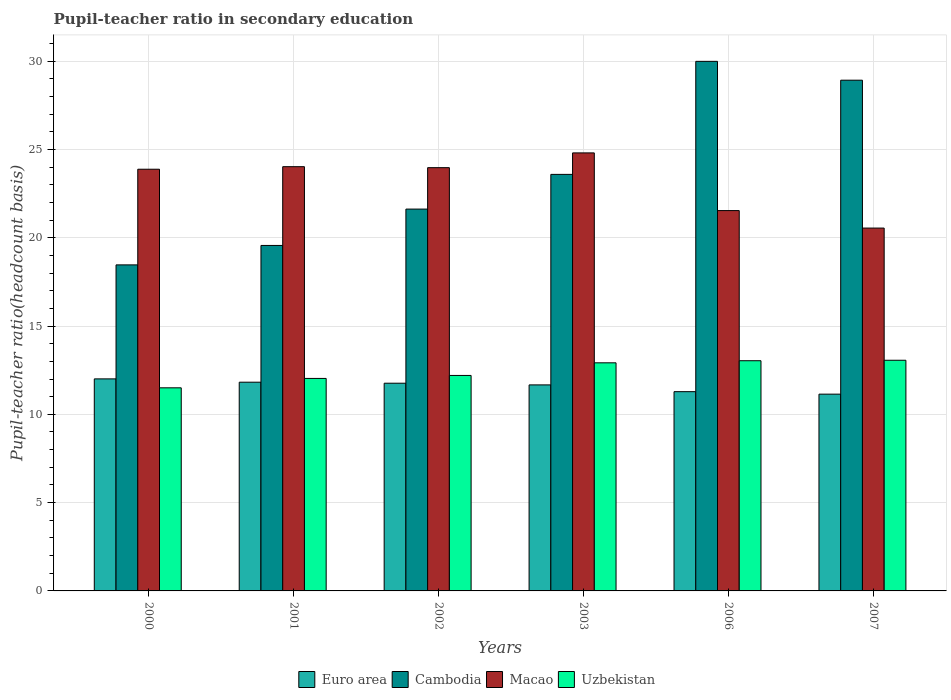How many different coloured bars are there?
Provide a succinct answer. 4. How many groups of bars are there?
Provide a short and direct response. 6. How many bars are there on the 4th tick from the right?
Keep it short and to the point. 4. What is the label of the 2nd group of bars from the left?
Your answer should be compact. 2001. In how many cases, is the number of bars for a given year not equal to the number of legend labels?
Provide a short and direct response. 0. What is the pupil-teacher ratio in secondary education in Uzbekistan in 2001?
Provide a succinct answer. 12.03. Across all years, what is the maximum pupil-teacher ratio in secondary education in Uzbekistan?
Give a very brief answer. 13.06. Across all years, what is the minimum pupil-teacher ratio in secondary education in Euro area?
Offer a terse response. 11.14. In which year was the pupil-teacher ratio in secondary education in Uzbekistan maximum?
Provide a short and direct response. 2007. What is the total pupil-teacher ratio in secondary education in Uzbekistan in the graph?
Provide a short and direct response. 74.75. What is the difference between the pupil-teacher ratio in secondary education in Uzbekistan in 2002 and that in 2003?
Your answer should be compact. -0.72. What is the difference between the pupil-teacher ratio in secondary education in Uzbekistan in 2000 and the pupil-teacher ratio in secondary education in Macao in 2006?
Offer a very short reply. -10.04. What is the average pupil-teacher ratio in secondary education in Euro area per year?
Your answer should be compact. 11.61. In the year 2002, what is the difference between the pupil-teacher ratio in secondary education in Uzbekistan and pupil-teacher ratio in secondary education in Euro area?
Keep it short and to the point. 0.44. What is the ratio of the pupil-teacher ratio in secondary education in Uzbekistan in 2003 to that in 2007?
Give a very brief answer. 0.99. Is the difference between the pupil-teacher ratio in secondary education in Uzbekistan in 2000 and 2001 greater than the difference between the pupil-teacher ratio in secondary education in Euro area in 2000 and 2001?
Make the answer very short. No. What is the difference between the highest and the second highest pupil-teacher ratio in secondary education in Uzbekistan?
Your response must be concise. 0.03. What is the difference between the highest and the lowest pupil-teacher ratio in secondary education in Macao?
Keep it short and to the point. 4.26. In how many years, is the pupil-teacher ratio in secondary education in Uzbekistan greater than the average pupil-teacher ratio in secondary education in Uzbekistan taken over all years?
Make the answer very short. 3. Is it the case that in every year, the sum of the pupil-teacher ratio in secondary education in Euro area and pupil-teacher ratio in secondary education in Cambodia is greater than the sum of pupil-teacher ratio in secondary education in Uzbekistan and pupil-teacher ratio in secondary education in Macao?
Your response must be concise. Yes. What does the 3rd bar from the left in 2001 represents?
Your response must be concise. Macao. What does the 2nd bar from the right in 2007 represents?
Ensure brevity in your answer.  Macao. Are all the bars in the graph horizontal?
Your answer should be very brief. No. What is the difference between two consecutive major ticks on the Y-axis?
Your answer should be compact. 5. Are the values on the major ticks of Y-axis written in scientific E-notation?
Provide a short and direct response. No. Does the graph contain any zero values?
Give a very brief answer. No. What is the title of the graph?
Make the answer very short. Pupil-teacher ratio in secondary education. Does "Ghana" appear as one of the legend labels in the graph?
Provide a succinct answer. No. What is the label or title of the X-axis?
Give a very brief answer. Years. What is the label or title of the Y-axis?
Offer a terse response. Pupil-teacher ratio(headcount basis). What is the Pupil-teacher ratio(headcount basis) of Euro area in 2000?
Give a very brief answer. 12.01. What is the Pupil-teacher ratio(headcount basis) in Cambodia in 2000?
Give a very brief answer. 18.46. What is the Pupil-teacher ratio(headcount basis) of Macao in 2000?
Your response must be concise. 23.88. What is the Pupil-teacher ratio(headcount basis) in Uzbekistan in 2000?
Make the answer very short. 11.5. What is the Pupil-teacher ratio(headcount basis) of Euro area in 2001?
Offer a very short reply. 11.82. What is the Pupil-teacher ratio(headcount basis) in Cambodia in 2001?
Your answer should be compact. 19.56. What is the Pupil-teacher ratio(headcount basis) of Macao in 2001?
Provide a short and direct response. 24.02. What is the Pupil-teacher ratio(headcount basis) in Uzbekistan in 2001?
Give a very brief answer. 12.03. What is the Pupil-teacher ratio(headcount basis) in Euro area in 2002?
Ensure brevity in your answer.  11.76. What is the Pupil-teacher ratio(headcount basis) in Cambodia in 2002?
Give a very brief answer. 21.62. What is the Pupil-teacher ratio(headcount basis) of Macao in 2002?
Provide a short and direct response. 23.97. What is the Pupil-teacher ratio(headcount basis) in Uzbekistan in 2002?
Your response must be concise. 12.2. What is the Pupil-teacher ratio(headcount basis) in Euro area in 2003?
Provide a short and direct response. 11.67. What is the Pupil-teacher ratio(headcount basis) in Cambodia in 2003?
Provide a succinct answer. 23.59. What is the Pupil-teacher ratio(headcount basis) in Macao in 2003?
Provide a short and direct response. 24.8. What is the Pupil-teacher ratio(headcount basis) in Uzbekistan in 2003?
Keep it short and to the point. 12.92. What is the Pupil-teacher ratio(headcount basis) in Euro area in 2006?
Offer a very short reply. 11.28. What is the Pupil-teacher ratio(headcount basis) of Cambodia in 2006?
Offer a terse response. 29.99. What is the Pupil-teacher ratio(headcount basis) of Macao in 2006?
Provide a short and direct response. 21.54. What is the Pupil-teacher ratio(headcount basis) of Uzbekistan in 2006?
Offer a very short reply. 13.04. What is the Pupil-teacher ratio(headcount basis) in Euro area in 2007?
Provide a short and direct response. 11.14. What is the Pupil-teacher ratio(headcount basis) of Cambodia in 2007?
Provide a short and direct response. 28.92. What is the Pupil-teacher ratio(headcount basis) of Macao in 2007?
Your answer should be compact. 20.55. What is the Pupil-teacher ratio(headcount basis) of Uzbekistan in 2007?
Provide a short and direct response. 13.06. Across all years, what is the maximum Pupil-teacher ratio(headcount basis) of Euro area?
Give a very brief answer. 12.01. Across all years, what is the maximum Pupil-teacher ratio(headcount basis) in Cambodia?
Make the answer very short. 29.99. Across all years, what is the maximum Pupil-teacher ratio(headcount basis) of Macao?
Your response must be concise. 24.8. Across all years, what is the maximum Pupil-teacher ratio(headcount basis) of Uzbekistan?
Ensure brevity in your answer.  13.06. Across all years, what is the minimum Pupil-teacher ratio(headcount basis) in Euro area?
Your response must be concise. 11.14. Across all years, what is the minimum Pupil-teacher ratio(headcount basis) in Cambodia?
Your answer should be very brief. 18.46. Across all years, what is the minimum Pupil-teacher ratio(headcount basis) in Macao?
Ensure brevity in your answer.  20.55. Across all years, what is the minimum Pupil-teacher ratio(headcount basis) of Uzbekistan?
Keep it short and to the point. 11.5. What is the total Pupil-teacher ratio(headcount basis) in Euro area in the graph?
Give a very brief answer. 69.68. What is the total Pupil-teacher ratio(headcount basis) in Cambodia in the graph?
Offer a terse response. 142.15. What is the total Pupil-teacher ratio(headcount basis) in Macao in the graph?
Your answer should be very brief. 138.76. What is the total Pupil-teacher ratio(headcount basis) in Uzbekistan in the graph?
Your response must be concise. 74.75. What is the difference between the Pupil-teacher ratio(headcount basis) of Euro area in 2000 and that in 2001?
Offer a terse response. 0.19. What is the difference between the Pupil-teacher ratio(headcount basis) in Cambodia in 2000 and that in 2001?
Give a very brief answer. -1.1. What is the difference between the Pupil-teacher ratio(headcount basis) of Macao in 2000 and that in 2001?
Offer a terse response. -0.14. What is the difference between the Pupil-teacher ratio(headcount basis) in Uzbekistan in 2000 and that in 2001?
Your response must be concise. -0.53. What is the difference between the Pupil-teacher ratio(headcount basis) in Euro area in 2000 and that in 2002?
Your answer should be very brief. 0.25. What is the difference between the Pupil-teacher ratio(headcount basis) in Cambodia in 2000 and that in 2002?
Your answer should be very brief. -3.16. What is the difference between the Pupil-teacher ratio(headcount basis) of Macao in 2000 and that in 2002?
Provide a short and direct response. -0.09. What is the difference between the Pupil-teacher ratio(headcount basis) of Uzbekistan in 2000 and that in 2002?
Provide a short and direct response. -0.7. What is the difference between the Pupil-teacher ratio(headcount basis) of Euro area in 2000 and that in 2003?
Make the answer very short. 0.34. What is the difference between the Pupil-teacher ratio(headcount basis) in Cambodia in 2000 and that in 2003?
Offer a terse response. -5.12. What is the difference between the Pupil-teacher ratio(headcount basis) in Macao in 2000 and that in 2003?
Make the answer very short. -0.92. What is the difference between the Pupil-teacher ratio(headcount basis) in Uzbekistan in 2000 and that in 2003?
Offer a terse response. -1.42. What is the difference between the Pupil-teacher ratio(headcount basis) in Euro area in 2000 and that in 2006?
Your answer should be very brief. 0.72. What is the difference between the Pupil-teacher ratio(headcount basis) in Cambodia in 2000 and that in 2006?
Offer a very short reply. -11.53. What is the difference between the Pupil-teacher ratio(headcount basis) of Macao in 2000 and that in 2006?
Ensure brevity in your answer.  2.34. What is the difference between the Pupil-teacher ratio(headcount basis) in Uzbekistan in 2000 and that in 2006?
Make the answer very short. -1.53. What is the difference between the Pupil-teacher ratio(headcount basis) in Euro area in 2000 and that in 2007?
Your answer should be compact. 0.86. What is the difference between the Pupil-teacher ratio(headcount basis) of Cambodia in 2000 and that in 2007?
Give a very brief answer. -10.46. What is the difference between the Pupil-teacher ratio(headcount basis) of Macao in 2000 and that in 2007?
Make the answer very short. 3.33. What is the difference between the Pupil-teacher ratio(headcount basis) of Uzbekistan in 2000 and that in 2007?
Offer a terse response. -1.56. What is the difference between the Pupil-teacher ratio(headcount basis) in Euro area in 2001 and that in 2002?
Offer a very short reply. 0.06. What is the difference between the Pupil-teacher ratio(headcount basis) of Cambodia in 2001 and that in 2002?
Make the answer very short. -2.06. What is the difference between the Pupil-teacher ratio(headcount basis) in Macao in 2001 and that in 2002?
Make the answer very short. 0.06. What is the difference between the Pupil-teacher ratio(headcount basis) of Uzbekistan in 2001 and that in 2002?
Your response must be concise. -0.17. What is the difference between the Pupil-teacher ratio(headcount basis) of Euro area in 2001 and that in 2003?
Keep it short and to the point. 0.15. What is the difference between the Pupil-teacher ratio(headcount basis) of Cambodia in 2001 and that in 2003?
Make the answer very short. -4.02. What is the difference between the Pupil-teacher ratio(headcount basis) in Macao in 2001 and that in 2003?
Offer a very short reply. -0.78. What is the difference between the Pupil-teacher ratio(headcount basis) in Uzbekistan in 2001 and that in 2003?
Ensure brevity in your answer.  -0.88. What is the difference between the Pupil-teacher ratio(headcount basis) in Euro area in 2001 and that in 2006?
Keep it short and to the point. 0.54. What is the difference between the Pupil-teacher ratio(headcount basis) of Cambodia in 2001 and that in 2006?
Make the answer very short. -10.42. What is the difference between the Pupil-teacher ratio(headcount basis) in Macao in 2001 and that in 2006?
Your answer should be compact. 2.49. What is the difference between the Pupil-teacher ratio(headcount basis) of Uzbekistan in 2001 and that in 2006?
Make the answer very short. -1. What is the difference between the Pupil-teacher ratio(headcount basis) of Euro area in 2001 and that in 2007?
Keep it short and to the point. 0.68. What is the difference between the Pupil-teacher ratio(headcount basis) of Cambodia in 2001 and that in 2007?
Provide a short and direct response. -9.36. What is the difference between the Pupil-teacher ratio(headcount basis) in Macao in 2001 and that in 2007?
Offer a terse response. 3.48. What is the difference between the Pupil-teacher ratio(headcount basis) of Uzbekistan in 2001 and that in 2007?
Make the answer very short. -1.03. What is the difference between the Pupil-teacher ratio(headcount basis) in Euro area in 2002 and that in 2003?
Your answer should be very brief. 0.1. What is the difference between the Pupil-teacher ratio(headcount basis) of Cambodia in 2002 and that in 2003?
Keep it short and to the point. -1.97. What is the difference between the Pupil-teacher ratio(headcount basis) in Macao in 2002 and that in 2003?
Keep it short and to the point. -0.84. What is the difference between the Pupil-teacher ratio(headcount basis) of Uzbekistan in 2002 and that in 2003?
Provide a succinct answer. -0.72. What is the difference between the Pupil-teacher ratio(headcount basis) of Euro area in 2002 and that in 2006?
Your answer should be compact. 0.48. What is the difference between the Pupil-teacher ratio(headcount basis) in Cambodia in 2002 and that in 2006?
Provide a short and direct response. -8.37. What is the difference between the Pupil-teacher ratio(headcount basis) in Macao in 2002 and that in 2006?
Keep it short and to the point. 2.43. What is the difference between the Pupil-teacher ratio(headcount basis) of Uzbekistan in 2002 and that in 2006?
Your response must be concise. -0.83. What is the difference between the Pupil-teacher ratio(headcount basis) of Euro area in 2002 and that in 2007?
Keep it short and to the point. 0.62. What is the difference between the Pupil-teacher ratio(headcount basis) in Cambodia in 2002 and that in 2007?
Provide a short and direct response. -7.3. What is the difference between the Pupil-teacher ratio(headcount basis) of Macao in 2002 and that in 2007?
Ensure brevity in your answer.  3.42. What is the difference between the Pupil-teacher ratio(headcount basis) in Uzbekistan in 2002 and that in 2007?
Provide a succinct answer. -0.86. What is the difference between the Pupil-teacher ratio(headcount basis) of Euro area in 2003 and that in 2006?
Ensure brevity in your answer.  0.38. What is the difference between the Pupil-teacher ratio(headcount basis) of Cambodia in 2003 and that in 2006?
Provide a short and direct response. -6.4. What is the difference between the Pupil-teacher ratio(headcount basis) in Macao in 2003 and that in 2006?
Provide a succinct answer. 3.27. What is the difference between the Pupil-teacher ratio(headcount basis) in Uzbekistan in 2003 and that in 2006?
Give a very brief answer. -0.12. What is the difference between the Pupil-teacher ratio(headcount basis) in Euro area in 2003 and that in 2007?
Your answer should be compact. 0.52. What is the difference between the Pupil-teacher ratio(headcount basis) of Cambodia in 2003 and that in 2007?
Your answer should be very brief. -5.33. What is the difference between the Pupil-teacher ratio(headcount basis) of Macao in 2003 and that in 2007?
Offer a terse response. 4.26. What is the difference between the Pupil-teacher ratio(headcount basis) in Uzbekistan in 2003 and that in 2007?
Your answer should be very brief. -0.15. What is the difference between the Pupil-teacher ratio(headcount basis) of Euro area in 2006 and that in 2007?
Keep it short and to the point. 0.14. What is the difference between the Pupil-teacher ratio(headcount basis) in Cambodia in 2006 and that in 2007?
Ensure brevity in your answer.  1.07. What is the difference between the Pupil-teacher ratio(headcount basis) in Macao in 2006 and that in 2007?
Your answer should be very brief. 0.99. What is the difference between the Pupil-teacher ratio(headcount basis) in Uzbekistan in 2006 and that in 2007?
Offer a terse response. -0.03. What is the difference between the Pupil-teacher ratio(headcount basis) of Euro area in 2000 and the Pupil-teacher ratio(headcount basis) of Cambodia in 2001?
Ensure brevity in your answer.  -7.56. What is the difference between the Pupil-teacher ratio(headcount basis) in Euro area in 2000 and the Pupil-teacher ratio(headcount basis) in Macao in 2001?
Ensure brevity in your answer.  -12.02. What is the difference between the Pupil-teacher ratio(headcount basis) of Euro area in 2000 and the Pupil-teacher ratio(headcount basis) of Uzbekistan in 2001?
Make the answer very short. -0.03. What is the difference between the Pupil-teacher ratio(headcount basis) of Cambodia in 2000 and the Pupil-teacher ratio(headcount basis) of Macao in 2001?
Keep it short and to the point. -5.56. What is the difference between the Pupil-teacher ratio(headcount basis) in Cambodia in 2000 and the Pupil-teacher ratio(headcount basis) in Uzbekistan in 2001?
Offer a very short reply. 6.43. What is the difference between the Pupil-teacher ratio(headcount basis) in Macao in 2000 and the Pupil-teacher ratio(headcount basis) in Uzbekistan in 2001?
Provide a succinct answer. 11.85. What is the difference between the Pupil-teacher ratio(headcount basis) of Euro area in 2000 and the Pupil-teacher ratio(headcount basis) of Cambodia in 2002?
Ensure brevity in your answer.  -9.62. What is the difference between the Pupil-teacher ratio(headcount basis) of Euro area in 2000 and the Pupil-teacher ratio(headcount basis) of Macao in 2002?
Provide a short and direct response. -11.96. What is the difference between the Pupil-teacher ratio(headcount basis) in Euro area in 2000 and the Pupil-teacher ratio(headcount basis) in Uzbekistan in 2002?
Ensure brevity in your answer.  -0.19. What is the difference between the Pupil-teacher ratio(headcount basis) of Cambodia in 2000 and the Pupil-teacher ratio(headcount basis) of Macao in 2002?
Your answer should be compact. -5.51. What is the difference between the Pupil-teacher ratio(headcount basis) of Cambodia in 2000 and the Pupil-teacher ratio(headcount basis) of Uzbekistan in 2002?
Your answer should be very brief. 6.26. What is the difference between the Pupil-teacher ratio(headcount basis) in Macao in 2000 and the Pupil-teacher ratio(headcount basis) in Uzbekistan in 2002?
Give a very brief answer. 11.68. What is the difference between the Pupil-teacher ratio(headcount basis) in Euro area in 2000 and the Pupil-teacher ratio(headcount basis) in Cambodia in 2003?
Ensure brevity in your answer.  -11.58. What is the difference between the Pupil-teacher ratio(headcount basis) of Euro area in 2000 and the Pupil-teacher ratio(headcount basis) of Macao in 2003?
Make the answer very short. -12.8. What is the difference between the Pupil-teacher ratio(headcount basis) in Euro area in 2000 and the Pupil-teacher ratio(headcount basis) in Uzbekistan in 2003?
Make the answer very short. -0.91. What is the difference between the Pupil-teacher ratio(headcount basis) of Cambodia in 2000 and the Pupil-teacher ratio(headcount basis) of Macao in 2003?
Your answer should be very brief. -6.34. What is the difference between the Pupil-teacher ratio(headcount basis) of Cambodia in 2000 and the Pupil-teacher ratio(headcount basis) of Uzbekistan in 2003?
Offer a terse response. 5.55. What is the difference between the Pupil-teacher ratio(headcount basis) of Macao in 2000 and the Pupil-teacher ratio(headcount basis) of Uzbekistan in 2003?
Offer a very short reply. 10.96. What is the difference between the Pupil-teacher ratio(headcount basis) of Euro area in 2000 and the Pupil-teacher ratio(headcount basis) of Cambodia in 2006?
Ensure brevity in your answer.  -17.98. What is the difference between the Pupil-teacher ratio(headcount basis) in Euro area in 2000 and the Pupil-teacher ratio(headcount basis) in Macao in 2006?
Your answer should be very brief. -9.53. What is the difference between the Pupil-teacher ratio(headcount basis) in Euro area in 2000 and the Pupil-teacher ratio(headcount basis) in Uzbekistan in 2006?
Give a very brief answer. -1.03. What is the difference between the Pupil-teacher ratio(headcount basis) of Cambodia in 2000 and the Pupil-teacher ratio(headcount basis) of Macao in 2006?
Ensure brevity in your answer.  -3.07. What is the difference between the Pupil-teacher ratio(headcount basis) in Cambodia in 2000 and the Pupil-teacher ratio(headcount basis) in Uzbekistan in 2006?
Offer a terse response. 5.43. What is the difference between the Pupil-teacher ratio(headcount basis) in Macao in 2000 and the Pupil-teacher ratio(headcount basis) in Uzbekistan in 2006?
Keep it short and to the point. 10.84. What is the difference between the Pupil-teacher ratio(headcount basis) of Euro area in 2000 and the Pupil-teacher ratio(headcount basis) of Cambodia in 2007?
Keep it short and to the point. -16.91. What is the difference between the Pupil-teacher ratio(headcount basis) of Euro area in 2000 and the Pupil-teacher ratio(headcount basis) of Macao in 2007?
Make the answer very short. -8.54. What is the difference between the Pupil-teacher ratio(headcount basis) in Euro area in 2000 and the Pupil-teacher ratio(headcount basis) in Uzbekistan in 2007?
Offer a very short reply. -1.05. What is the difference between the Pupil-teacher ratio(headcount basis) in Cambodia in 2000 and the Pupil-teacher ratio(headcount basis) in Macao in 2007?
Provide a succinct answer. -2.08. What is the difference between the Pupil-teacher ratio(headcount basis) in Cambodia in 2000 and the Pupil-teacher ratio(headcount basis) in Uzbekistan in 2007?
Offer a terse response. 5.4. What is the difference between the Pupil-teacher ratio(headcount basis) in Macao in 2000 and the Pupil-teacher ratio(headcount basis) in Uzbekistan in 2007?
Provide a short and direct response. 10.82. What is the difference between the Pupil-teacher ratio(headcount basis) in Euro area in 2001 and the Pupil-teacher ratio(headcount basis) in Cambodia in 2002?
Make the answer very short. -9.8. What is the difference between the Pupil-teacher ratio(headcount basis) of Euro area in 2001 and the Pupil-teacher ratio(headcount basis) of Macao in 2002?
Ensure brevity in your answer.  -12.15. What is the difference between the Pupil-teacher ratio(headcount basis) in Euro area in 2001 and the Pupil-teacher ratio(headcount basis) in Uzbekistan in 2002?
Offer a terse response. -0.38. What is the difference between the Pupil-teacher ratio(headcount basis) in Cambodia in 2001 and the Pupil-teacher ratio(headcount basis) in Macao in 2002?
Provide a short and direct response. -4.4. What is the difference between the Pupil-teacher ratio(headcount basis) in Cambodia in 2001 and the Pupil-teacher ratio(headcount basis) in Uzbekistan in 2002?
Provide a short and direct response. 7.36. What is the difference between the Pupil-teacher ratio(headcount basis) in Macao in 2001 and the Pupil-teacher ratio(headcount basis) in Uzbekistan in 2002?
Give a very brief answer. 11.82. What is the difference between the Pupil-teacher ratio(headcount basis) in Euro area in 2001 and the Pupil-teacher ratio(headcount basis) in Cambodia in 2003?
Provide a short and direct response. -11.77. What is the difference between the Pupil-teacher ratio(headcount basis) of Euro area in 2001 and the Pupil-teacher ratio(headcount basis) of Macao in 2003?
Offer a terse response. -12.98. What is the difference between the Pupil-teacher ratio(headcount basis) in Euro area in 2001 and the Pupil-teacher ratio(headcount basis) in Uzbekistan in 2003?
Keep it short and to the point. -1.1. What is the difference between the Pupil-teacher ratio(headcount basis) in Cambodia in 2001 and the Pupil-teacher ratio(headcount basis) in Macao in 2003?
Your answer should be compact. -5.24. What is the difference between the Pupil-teacher ratio(headcount basis) in Cambodia in 2001 and the Pupil-teacher ratio(headcount basis) in Uzbekistan in 2003?
Your response must be concise. 6.65. What is the difference between the Pupil-teacher ratio(headcount basis) of Macao in 2001 and the Pupil-teacher ratio(headcount basis) of Uzbekistan in 2003?
Give a very brief answer. 11.11. What is the difference between the Pupil-teacher ratio(headcount basis) in Euro area in 2001 and the Pupil-teacher ratio(headcount basis) in Cambodia in 2006?
Make the answer very short. -18.17. What is the difference between the Pupil-teacher ratio(headcount basis) in Euro area in 2001 and the Pupil-teacher ratio(headcount basis) in Macao in 2006?
Provide a short and direct response. -9.72. What is the difference between the Pupil-teacher ratio(headcount basis) in Euro area in 2001 and the Pupil-teacher ratio(headcount basis) in Uzbekistan in 2006?
Provide a short and direct response. -1.22. What is the difference between the Pupil-teacher ratio(headcount basis) of Cambodia in 2001 and the Pupil-teacher ratio(headcount basis) of Macao in 2006?
Ensure brevity in your answer.  -1.97. What is the difference between the Pupil-teacher ratio(headcount basis) in Cambodia in 2001 and the Pupil-teacher ratio(headcount basis) in Uzbekistan in 2006?
Provide a succinct answer. 6.53. What is the difference between the Pupil-teacher ratio(headcount basis) in Macao in 2001 and the Pupil-teacher ratio(headcount basis) in Uzbekistan in 2006?
Ensure brevity in your answer.  10.99. What is the difference between the Pupil-teacher ratio(headcount basis) of Euro area in 2001 and the Pupil-teacher ratio(headcount basis) of Cambodia in 2007?
Make the answer very short. -17.1. What is the difference between the Pupil-teacher ratio(headcount basis) of Euro area in 2001 and the Pupil-teacher ratio(headcount basis) of Macao in 2007?
Your answer should be compact. -8.73. What is the difference between the Pupil-teacher ratio(headcount basis) in Euro area in 2001 and the Pupil-teacher ratio(headcount basis) in Uzbekistan in 2007?
Offer a very short reply. -1.24. What is the difference between the Pupil-teacher ratio(headcount basis) of Cambodia in 2001 and the Pupil-teacher ratio(headcount basis) of Macao in 2007?
Your answer should be compact. -0.98. What is the difference between the Pupil-teacher ratio(headcount basis) of Cambodia in 2001 and the Pupil-teacher ratio(headcount basis) of Uzbekistan in 2007?
Offer a terse response. 6.5. What is the difference between the Pupil-teacher ratio(headcount basis) in Macao in 2001 and the Pupil-teacher ratio(headcount basis) in Uzbekistan in 2007?
Keep it short and to the point. 10.96. What is the difference between the Pupil-teacher ratio(headcount basis) of Euro area in 2002 and the Pupil-teacher ratio(headcount basis) of Cambodia in 2003?
Provide a succinct answer. -11.83. What is the difference between the Pupil-teacher ratio(headcount basis) of Euro area in 2002 and the Pupil-teacher ratio(headcount basis) of Macao in 2003?
Ensure brevity in your answer.  -13.04. What is the difference between the Pupil-teacher ratio(headcount basis) in Euro area in 2002 and the Pupil-teacher ratio(headcount basis) in Uzbekistan in 2003?
Make the answer very short. -1.16. What is the difference between the Pupil-teacher ratio(headcount basis) in Cambodia in 2002 and the Pupil-teacher ratio(headcount basis) in Macao in 2003?
Provide a succinct answer. -3.18. What is the difference between the Pupil-teacher ratio(headcount basis) in Cambodia in 2002 and the Pupil-teacher ratio(headcount basis) in Uzbekistan in 2003?
Make the answer very short. 8.71. What is the difference between the Pupil-teacher ratio(headcount basis) in Macao in 2002 and the Pupil-teacher ratio(headcount basis) in Uzbekistan in 2003?
Offer a very short reply. 11.05. What is the difference between the Pupil-teacher ratio(headcount basis) of Euro area in 2002 and the Pupil-teacher ratio(headcount basis) of Cambodia in 2006?
Your answer should be compact. -18.23. What is the difference between the Pupil-teacher ratio(headcount basis) of Euro area in 2002 and the Pupil-teacher ratio(headcount basis) of Macao in 2006?
Give a very brief answer. -9.78. What is the difference between the Pupil-teacher ratio(headcount basis) of Euro area in 2002 and the Pupil-teacher ratio(headcount basis) of Uzbekistan in 2006?
Give a very brief answer. -1.27. What is the difference between the Pupil-teacher ratio(headcount basis) of Cambodia in 2002 and the Pupil-teacher ratio(headcount basis) of Macao in 2006?
Your response must be concise. 0.08. What is the difference between the Pupil-teacher ratio(headcount basis) in Cambodia in 2002 and the Pupil-teacher ratio(headcount basis) in Uzbekistan in 2006?
Provide a succinct answer. 8.59. What is the difference between the Pupil-teacher ratio(headcount basis) in Macao in 2002 and the Pupil-teacher ratio(headcount basis) in Uzbekistan in 2006?
Your answer should be compact. 10.93. What is the difference between the Pupil-teacher ratio(headcount basis) of Euro area in 2002 and the Pupil-teacher ratio(headcount basis) of Cambodia in 2007?
Make the answer very short. -17.16. What is the difference between the Pupil-teacher ratio(headcount basis) in Euro area in 2002 and the Pupil-teacher ratio(headcount basis) in Macao in 2007?
Your response must be concise. -8.79. What is the difference between the Pupil-teacher ratio(headcount basis) in Euro area in 2002 and the Pupil-teacher ratio(headcount basis) in Uzbekistan in 2007?
Offer a very short reply. -1.3. What is the difference between the Pupil-teacher ratio(headcount basis) in Cambodia in 2002 and the Pupil-teacher ratio(headcount basis) in Macao in 2007?
Your answer should be compact. 1.08. What is the difference between the Pupil-teacher ratio(headcount basis) in Cambodia in 2002 and the Pupil-teacher ratio(headcount basis) in Uzbekistan in 2007?
Offer a very short reply. 8.56. What is the difference between the Pupil-teacher ratio(headcount basis) of Macao in 2002 and the Pupil-teacher ratio(headcount basis) of Uzbekistan in 2007?
Your answer should be very brief. 10.91. What is the difference between the Pupil-teacher ratio(headcount basis) of Euro area in 2003 and the Pupil-teacher ratio(headcount basis) of Cambodia in 2006?
Provide a short and direct response. -18.32. What is the difference between the Pupil-teacher ratio(headcount basis) of Euro area in 2003 and the Pupil-teacher ratio(headcount basis) of Macao in 2006?
Offer a very short reply. -9.87. What is the difference between the Pupil-teacher ratio(headcount basis) of Euro area in 2003 and the Pupil-teacher ratio(headcount basis) of Uzbekistan in 2006?
Keep it short and to the point. -1.37. What is the difference between the Pupil-teacher ratio(headcount basis) of Cambodia in 2003 and the Pupil-teacher ratio(headcount basis) of Macao in 2006?
Offer a terse response. 2.05. What is the difference between the Pupil-teacher ratio(headcount basis) in Cambodia in 2003 and the Pupil-teacher ratio(headcount basis) in Uzbekistan in 2006?
Provide a short and direct response. 10.55. What is the difference between the Pupil-teacher ratio(headcount basis) of Macao in 2003 and the Pupil-teacher ratio(headcount basis) of Uzbekistan in 2006?
Ensure brevity in your answer.  11.77. What is the difference between the Pupil-teacher ratio(headcount basis) in Euro area in 2003 and the Pupil-teacher ratio(headcount basis) in Cambodia in 2007?
Ensure brevity in your answer.  -17.26. What is the difference between the Pupil-teacher ratio(headcount basis) in Euro area in 2003 and the Pupil-teacher ratio(headcount basis) in Macao in 2007?
Offer a very short reply. -8.88. What is the difference between the Pupil-teacher ratio(headcount basis) in Euro area in 2003 and the Pupil-teacher ratio(headcount basis) in Uzbekistan in 2007?
Offer a very short reply. -1.4. What is the difference between the Pupil-teacher ratio(headcount basis) in Cambodia in 2003 and the Pupil-teacher ratio(headcount basis) in Macao in 2007?
Keep it short and to the point. 3.04. What is the difference between the Pupil-teacher ratio(headcount basis) of Cambodia in 2003 and the Pupil-teacher ratio(headcount basis) of Uzbekistan in 2007?
Offer a terse response. 10.53. What is the difference between the Pupil-teacher ratio(headcount basis) in Macao in 2003 and the Pupil-teacher ratio(headcount basis) in Uzbekistan in 2007?
Make the answer very short. 11.74. What is the difference between the Pupil-teacher ratio(headcount basis) in Euro area in 2006 and the Pupil-teacher ratio(headcount basis) in Cambodia in 2007?
Offer a terse response. -17.64. What is the difference between the Pupil-teacher ratio(headcount basis) of Euro area in 2006 and the Pupil-teacher ratio(headcount basis) of Macao in 2007?
Your answer should be compact. -9.26. What is the difference between the Pupil-teacher ratio(headcount basis) of Euro area in 2006 and the Pupil-teacher ratio(headcount basis) of Uzbekistan in 2007?
Keep it short and to the point. -1.78. What is the difference between the Pupil-teacher ratio(headcount basis) of Cambodia in 2006 and the Pupil-teacher ratio(headcount basis) of Macao in 2007?
Offer a terse response. 9.44. What is the difference between the Pupil-teacher ratio(headcount basis) of Cambodia in 2006 and the Pupil-teacher ratio(headcount basis) of Uzbekistan in 2007?
Provide a short and direct response. 16.93. What is the difference between the Pupil-teacher ratio(headcount basis) in Macao in 2006 and the Pupil-teacher ratio(headcount basis) in Uzbekistan in 2007?
Give a very brief answer. 8.48. What is the average Pupil-teacher ratio(headcount basis) of Euro area per year?
Make the answer very short. 11.61. What is the average Pupil-teacher ratio(headcount basis) of Cambodia per year?
Make the answer very short. 23.69. What is the average Pupil-teacher ratio(headcount basis) of Macao per year?
Offer a very short reply. 23.13. What is the average Pupil-teacher ratio(headcount basis) of Uzbekistan per year?
Your response must be concise. 12.46. In the year 2000, what is the difference between the Pupil-teacher ratio(headcount basis) in Euro area and Pupil-teacher ratio(headcount basis) in Cambodia?
Provide a succinct answer. -6.46. In the year 2000, what is the difference between the Pupil-teacher ratio(headcount basis) in Euro area and Pupil-teacher ratio(headcount basis) in Macao?
Provide a short and direct response. -11.87. In the year 2000, what is the difference between the Pupil-teacher ratio(headcount basis) in Euro area and Pupil-teacher ratio(headcount basis) in Uzbekistan?
Make the answer very short. 0.51. In the year 2000, what is the difference between the Pupil-teacher ratio(headcount basis) in Cambodia and Pupil-teacher ratio(headcount basis) in Macao?
Offer a very short reply. -5.42. In the year 2000, what is the difference between the Pupil-teacher ratio(headcount basis) in Cambodia and Pupil-teacher ratio(headcount basis) in Uzbekistan?
Keep it short and to the point. 6.96. In the year 2000, what is the difference between the Pupil-teacher ratio(headcount basis) of Macao and Pupil-teacher ratio(headcount basis) of Uzbekistan?
Give a very brief answer. 12.38. In the year 2001, what is the difference between the Pupil-teacher ratio(headcount basis) of Euro area and Pupil-teacher ratio(headcount basis) of Cambodia?
Offer a very short reply. -7.74. In the year 2001, what is the difference between the Pupil-teacher ratio(headcount basis) in Euro area and Pupil-teacher ratio(headcount basis) in Macao?
Offer a very short reply. -12.2. In the year 2001, what is the difference between the Pupil-teacher ratio(headcount basis) in Euro area and Pupil-teacher ratio(headcount basis) in Uzbekistan?
Your response must be concise. -0.21. In the year 2001, what is the difference between the Pupil-teacher ratio(headcount basis) of Cambodia and Pupil-teacher ratio(headcount basis) of Macao?
Offer a terse response. -4.46. In the year 2001, what is the difference between the Pupil-teacher ratio(headcount basis) in Cambodia and Pupil-teacher ratio(headcount basis) in Uzbekistan?
Ensure brevity in your answer.  7.53. In the year 2001, what is the difference between the Pupil-teacher ratio(headcount basis) of Macao and Pupil-teacher ratio(headcount basis) of Uzbekistan?
Ensure brevity in your answer.  11.99. In the year 2002, what is the difference between the Pupil-teacher ratio(headcount basis) in Euro area and Pupil-teacher ratio(headcount basis) in Cambodia?
Ensure brevity in your answer.  -9.86. In the year 2002, what is the difference between the Pupil-teacher ratio(headcount basis) in Euro area and Pupil-teacher ratio(headcount basis) in Macao?
Your response must be concise. -12.21. In the year 2002, what is the difference between the Pupil-teacher ratio(headcount basis) in Euro area and Pupil-teacher ratio(headcount basis) in Uzbekistan?
Give a very brief answer. -0.44. In the year 2002, what is the difference between the Pupil-teacher ratio(headcount basis) in Cambodia and Pupil-teacher ratio(headcount basis) in Macao?
Ensure brevity in your answer.  -2.35. In the year 2002, what is the difference between the Pupil-teacher ratio(headcount basis) of Cambodia and Pupil-teacher ratio(headcount basis) of Uzbekistan?
Provide a succinct answer. 9.42. In the year 2002, what is the difference between the Pupil-teacher ratio(headcount basis) in Macao and Pupil-teacher ratio(headcount basis) in Uzbekistan?
Ensure brevity in your answer.  11.77. In the year 2003, what is the difference between the Pupil-teacher ratio(headcount basis) of Euro area and Pupil-teacher ratio(headcount basis) of Cambodia?
Your answer should be compact. -11.92. In the year 2003, what is the difference between the Pupil-teacher ratio(headcount basis) of Euro area and Pupil-teacher ratio(headcount basis) of Macao?
Offer a very short reply. -13.14. In the year 2003, what is the difference between the Pupil-teacher ratio(headcount basis) in Euro area and Pupil-teacher ratio(headcount basis) in Uzbekistan?
Offer a very short reply. -1.25. In the year 2003, what is the difference between the Pupil-teacher ratio(headcount basis) in Cambodia and Pupil-teacher ratio(headcount basis) in Macao?
Keep it short and to the point. -1.22. In the year 2003, what is the difference between the Pupil-teacher ratio(headcount basis) of Cambodia and Pupil-teacher ratio(headcount basis) of Uzbekistan?
Keep it short and to the point. 10.67. In the year 2003, what is the difference between the Pupil-teacher ratio(headcount basis) in Macao and Pupil-teacher ratio(headcount basis) in Uzbekistan?
Offer a terse response. 11.89. In the year 2006, what is the difference between the Pupil-teacher ratio(headcount basis) in Euro area and Pupil-teacher ratio(headcount basis) in Cambodia?
Keep it short and to the point. -18.71. In the year 2006, what is the difference between the Pupil-teacher ratio(headcount basis) of Euro area and Pupil-teacher ratio(headcount basis) of Macao?
Make the answer very short. -10.25. In the year 2006, what is the difference between the Pupil-teacher ratio(headcount basis) in Euro area and Pupil-teacher ratio(headcount basis) in Uzbekistan?
Provide a succinct answer. -1.75. In the year 2006, what is the difference between the Pupil-teacher ratio(headcount basis) in Cambodia and Pupil-teacher ratio(headcount basis) in Macao?
Give a very brief answer. 8.45. In the year 2006, what is the difference between the Pupil-teacher ratio(headcount basis) of Cambodia and Pupil-teacher ratio(headcount basis) of Uzbekistan?
Offer a terse response. 16.95. In the year 2006, what is the difference between the Pupil-teacher ratio(headcount basis) of Macao and Pupil-teacher ratio(headcount basis) of Uzbekistan?
Provide a short and direct response. 8.5. In the year 2007, what is the difference between the Pupil-teacher ratio(headcount basis) in Euro area and Pupil-teacher ratio(headcount basis) in Cambodia?
Provide a short and direct response. -17.78. In the year 2007, what is the difference between the Pupil-teacher ratio(headcount basis) of Euro area and Pupil-teacher ratio(headcount basis) of Macao?
Provide a short and direct response. -9.4. In the year 2007, what is the difference between the Pupil-teacher ratio(headcount basis) of Euro area and Pupil-teacher ratio(headcount basis) of Uzbekistan?
Your answer should be very brief. -1.92. In the year 2007, what is the difference between the Pupil-teacher ratio(headcount basis) of Cambodia and Pupil-teacher ratio(headcount basis) of Macao?
Offer a very short reply. 8.37. In the year 2007, what is the difference between the Pupil-teacher ratio(headcount basis) of Cambodia and Pupil-teacher ratio(headcount basis) of Uzbekistan?
Your answer should be very brief. 15.86. In the year 2007, what is the difference between the Pupil-teacher ratio(headcount basis) in Macao and Pupil-teacher ratio(headcount basis) in Uzbekistan?
Make the answer very short. 7.48. What is the ratio of the Pupil-teacher ratio(headcount basis) of Euro area in 2000 to that in 2001?
Your answer should be very brief. 1.02. What is the ratio of the Pupil-teacher ratio(headcount basis) in Cambodia in 2000 to that in 2001?
Ensure brevity in your answer.  0.94. What is the ratio of the Pupil-teacher ratio(headcount basis) of Uzbekistan in 2000 to that in 2001?
Your answer should be compact. 0.96. What is the ratio of the Pupil-teacher ratio(headcount basis) of Euro area in 2000 to that in 2002?
Give a very brief answer. 1.02. What is the ratio of the Pupil-teacher ratio(headcount basis) in Cambodia in 2000 to that in 2002?
Make the answer very short. 0.85. What is the ratio of the Pupil-teacher ratio(headcount basis) of Macao in 2000 to that in 2002?
Ensure brevity in your answer.  1. What is the ratio of the Pupil-teacher ratio(headcount basis) of Uzbekistan in 2000 to that in 2002?
Your response must be concise. 0.94. What is the ratio of the Pupil-teacher ratio(headcount basis) of Euro area in 2000 to that in 2003?
Keep it short and to the point. 1.03. What is the ratio of the Pupil-teacher ratio(headcount basis) of Cambodia in 2000 to that in 2003?
Make the answer very short. 0.78. What is the ratio of the Pupil-teacher ratio(headcount basis) of Macao in 2000 to that in 2003?
Offer a terse response. 0.96. What is the ratio of the Pupil-teacher ratio(headcount basis) of Uzbekistan in 2000 to that in 2003?
Provide a short and direct response. 0.89. What is the ratio of the Pupil-teacher ratio(headcount basis) in Euro area in 2000 to that in 2006?
Provide a short and direct response. 1.06. What is the ratio of the Pupil-teacher ratio(headcount basis) of Cambodia in 2000 to that in 2006?
Your answer should be compact. 0.62. What is the ratio of the Pupil-teacher ratio(headcount basis) of Macao in 2000 to that in 2006?
Make the answer very short. 1.11. What is the ratio of the Pupil-teacher ratio(headcount basis) in Uzbekistan in 2000 to that in 2006?
Make the answer very short. 0.88. What is the ratio of the Pupil-teacher ratio(headcount basis) of Euro area in 2000 to that in 2007?
Your answer should be compact. 1.08. What is the ratio of the Pupil-teacher ratio(headcount basis) in Cambodia in 2000 to that in 2007?
Offer a terse response. 0.64. What is the ratio of the Pupil-teacher ratio(headcount basis) of Macao in 2000 to that in 2007?
Ensure brevity in your answer.  1.16. What is the ratio of the Pupil-teacher ratio(headcount basis) of Uzbekistan in 2000 to that in 2007?
Ensure brevity in your answer.  0.88. What is the ratio of the Pupil-teacher ratio(headcount basis) of Cambodia in 2001 to that in 2002?
Give a very brief answer. 0.9. What is the ratio of the Pupil-teacher ratio(headcount basis) in Macao in 2001 to that in 2002?
Keep it short and to the point. 1. What is the ratio of the Pupil-teacher ratio(headcount basis) in Uzbekistan in 2001 to that in 2002?
Offer a terse response. 0.99. What is the ratio of the Pupil-teacher ratio(headcount basis) in Euro area in 2001 to that in 2003?
Offer a terse response. 1.01. What is the ratio of the Pupil-teacher ratio(headcount basis) of Cambodia in 2001 to that in 2003?
Make the answer very short. 0.83. What is the ratio of the Pupil-teacher ratio(headcount basis) in Macao in 2001 to that in 2003?
Provide a succinct answer. 0.97. What is the ratio of the Pupil-teacher ratio(headcount basis) in Uzbekistan in 2001 to that in 2003?
Offer a terse response. 0.93. What is the ratio of the Pupil-teacher ratio(headcount basis) of Euro area in 2001 to that in 2006?
Your answer should be very brief. 1.05. What is the ratio of the Pupil-teacher ratio(headcount basis) of Cambodia in 2001 to that in 2006?
Your answer should be compact. 0.65. What is the ratio of the Pupil-teacher ratio(headcount basis) of Macao in 2001 to that in 2006?
Your response must be concise. 1.12. What is the ratio of the Pupil-teacher ratio(headcount basis) of Uzbekistan in 2001 to that in 2006?
Provide a short and direct response. 0.92. What is the ratio of the Pupil-teacher ratio(headcount basis) of Euro area in 2001 to that in 2007?
Ensure brevity in your answer.  1.06. What is the ratio of the Pupil-teacher ratio(headcount basis) of Cambodia in 2001 to that in 2007?
Give a very brief answer. 0.68. What is the ratio of the Pupil-teacher ratio(headcount basis) of Macao in 2001 to that in 2007?
Your answer should be compact. 1.17. What is the ratio of the Pupil-teacher ratio(headcount basis) in Uzbekistan in 2001 to that in 2007?
Ensure brevity in your answer.  0.92. What is the ratio of the Pupil-teacher ratio(headcount basis) in Euro area in 2002 to that in 2003?
Your response must be concise. 1.01. What is the ratio of the Pupil-teacher ratio(headcount basis) in Cambodia in 2002 to that in 2003?
Offer a very short reply. 0.92. What is the ratio of the Pupil-teacher ratio(headcount basis) of Macao in 2002 to that in 2003?
Provide a short and direct response. 0.97. What is the ratio of the Pupil-teacher ratio(headcount basis) in Uzbekistan in 2002 to that in 2003?
Your response must be concise. 0.94. What is the ratio of the Pupil-teacher ratio(headcount basis) of Euro area in 2002 to that in 2006?
Keep it short and to the point. 1.04. What is the ratio of the Pupil-teacher ratio(headcount basis) in Cambodia in 2002 to that in 2006?
Your answer should be very brief. 0.72. What is the ratio of the Pupil-teacher ratio(headcount basis) of Macao in 2002 to that in 2006?
Offer a terse response. 1.11. What is the ratio of the Pupil-teacher ratio(headcount basis) in Uzbekistan in 2002 to that in 2006?
Your answer should be compact. 0.94. What is the ratio of the Pupil-teacher ratio(headcount basis) of Euro area in 2002 to that in 2007?
Offer a terse response. 1.06. What is the ratio of the Pupil-teacher ratio(headcount basis) in Cambodia in 2002 to that in 2007?
Give a very brief answer. 0.75. What is the ratio of the Pupil-teacher ratio(headcount basis) in Macao in 2002 to that in 2007?
Provide a succinct answer. 1.17. What is the ratio of the Pupil-teacher ratio(headcount basis) of Uzbekistan in 2002 to that in 2007?
Provide a succinct answer. 0.93. What is the ratio of the Pupil-teacher ratio(headcount basis) of Euro area in 2003 to that in 2006?
Give a very brief answer. 1.03. What is the ratio of the Pupil-teacher ratio(headcount basis) of Cambodia in 2003 to that in 2006?
Ensure brevity in your answer.  0.79. What is the ratio of the Pupil-teacher ratio(headcount basis) of Macao in 2003 to that in 2006?
Ensure brevity in your answer.  1.15. What is the ratio of the Pupil-teacher ratio(headcount basis) of Uzbekistan in 2003 to that in 2006?
Offer a very short reply. 0.99. What is the ratio of the Pupil-teacher ratio(headcount basis) of Euro area in 2003 to that in 2007?
Give a very brief answer. 1.05. What is the ratio of the Pupil-teacher ratio(headcount basis) in Cambodia in 2003 to that in 2007?
Your answer should be compact. 0.82. What is the ratio of the Pupil-teacher ratio(headcount basis) in Macao in 2003 to that in 2007?
Your answer should be compact. 1.21. What is the ratio of the Pupil-teacher ratio(headcount basis) of Uzbekistan in 2003 to that in 2007?
Ensure brevity in your answer.  0.99. What is the ratio of the Pupil-teacher ratio(headcount basis) in Euro area in 2006 to that in 2007?
Give a very brief answer. 1.01. What is the ratio of the Pupil-teacher ratio(headcount basis) in Cambodia in 2006 to that in 2007?
Offer a terse response. 1.04. What is the ratio of the Pupil-teacher ratio(headcount basis) of Macao in 2006 to that in 2007?
Offer a very short reply. 1.05. What is the ratio of the Pupil-teacher ratio(headcount basis) in Uzbekistan in 2006 to that in 2007?
Ensure brevity in your answer.  1. What is the difference between the highest and the second highest Pupil-teacher ratio(headcount basis) of Euro area?
Your answer should be very brief. 0.19. What is the difference between the highest and the second highest Pupil-teacher ratio(headcount basis) of Cambodia?
Your answer should be very brief. 1.07. What is the difference between the highest and the second highest Pupil-teacher ratio(headcount basis) of Macao?
Give a very brief answer. 0.78. What is the difference between the highest and the second highest Pupil-teacher ratio(headcount basis) in Uzbekistan?
Provide a succinct answer. 0.03. What is the difference between the highest and the lowest Pupil-teacher ratio(headcount basis) of Euro area?
Provide a short and direct response. 0.86. What is the difference between the highest and the lowest Pupil-teacher ratio(headcount basis) of Cambodia?
Give a very brief answer. 11.53. What is the difference between the highest and the lowest Pupil-teacher ratio(headcount basis) of Macao?
Provide a short and direct response. 4.26. What is the difference between the highest and the lowest Pupil-teacher ratio(headcount basis) of Uzbekistan?
Your answer should be very brief. 1.56. 